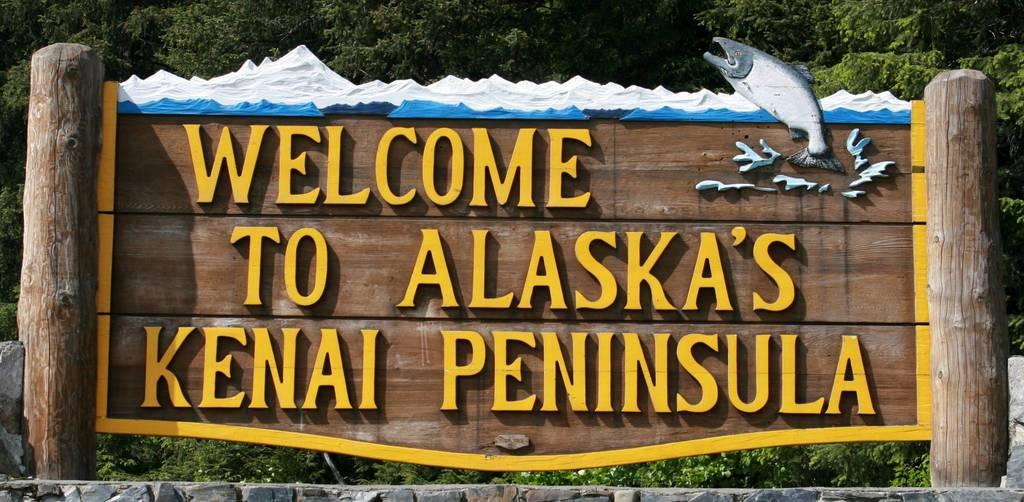What is the main object in the image? There is a board in the image. What is depicted on the board? There is a picture of a fish on the board. Are there any words or phrases on the board? Yes, there is text written on the board. What can be seen in the background of the image? There are trees in the background of the image. What type of industry is depicted in the image? There is no industry depicted in the image; it features a board with a picture of a fish and text. What kind of food is being prepared in the image? There is no food preparation visible in the image; it only shows a board with a picture of a fish and text. 